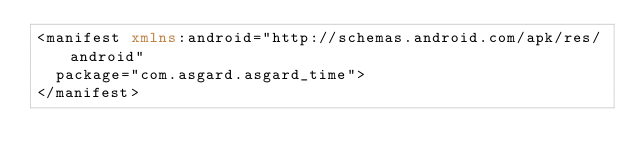Convert code to text. <code><loc_0><loc_0><loc_500><loc_500><_XML_><manifest xmlns:android="http://schemas.android.com/apk/res/android"
  package="com.asgard.asgard_time">
</manifest>
</code> 